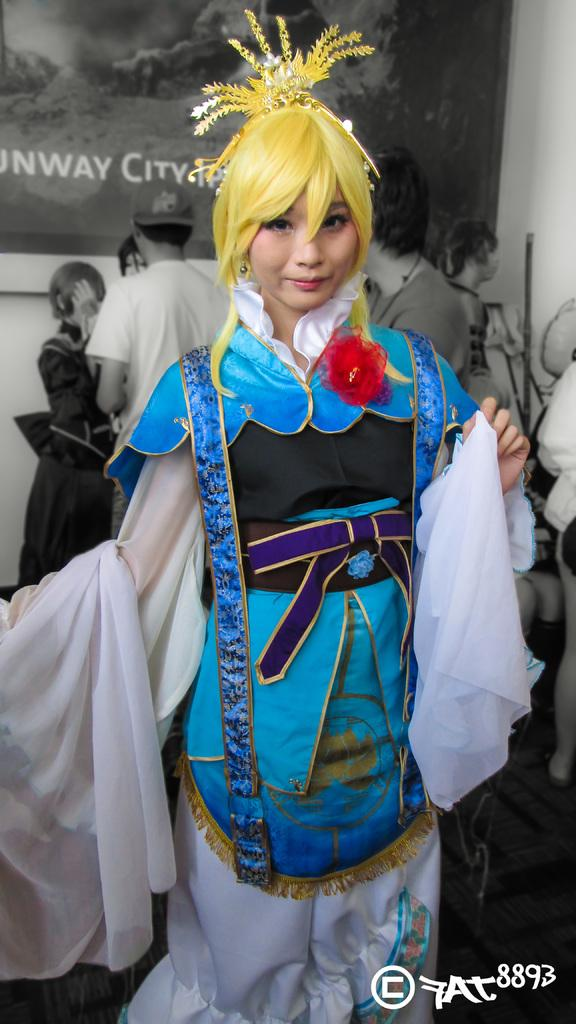What is the person in the image wearing? There is a person in a fancy dress in the image. What can be seen in the background of the image? There is a group of people standing and a wall poster in the background of the image. Is there any additional information about the image itself? Yes, there is a watermark on the image. What type of fingerprint can be seen on the wall poster in the image? There is no fingerprint visible on the wall poster in the image. 